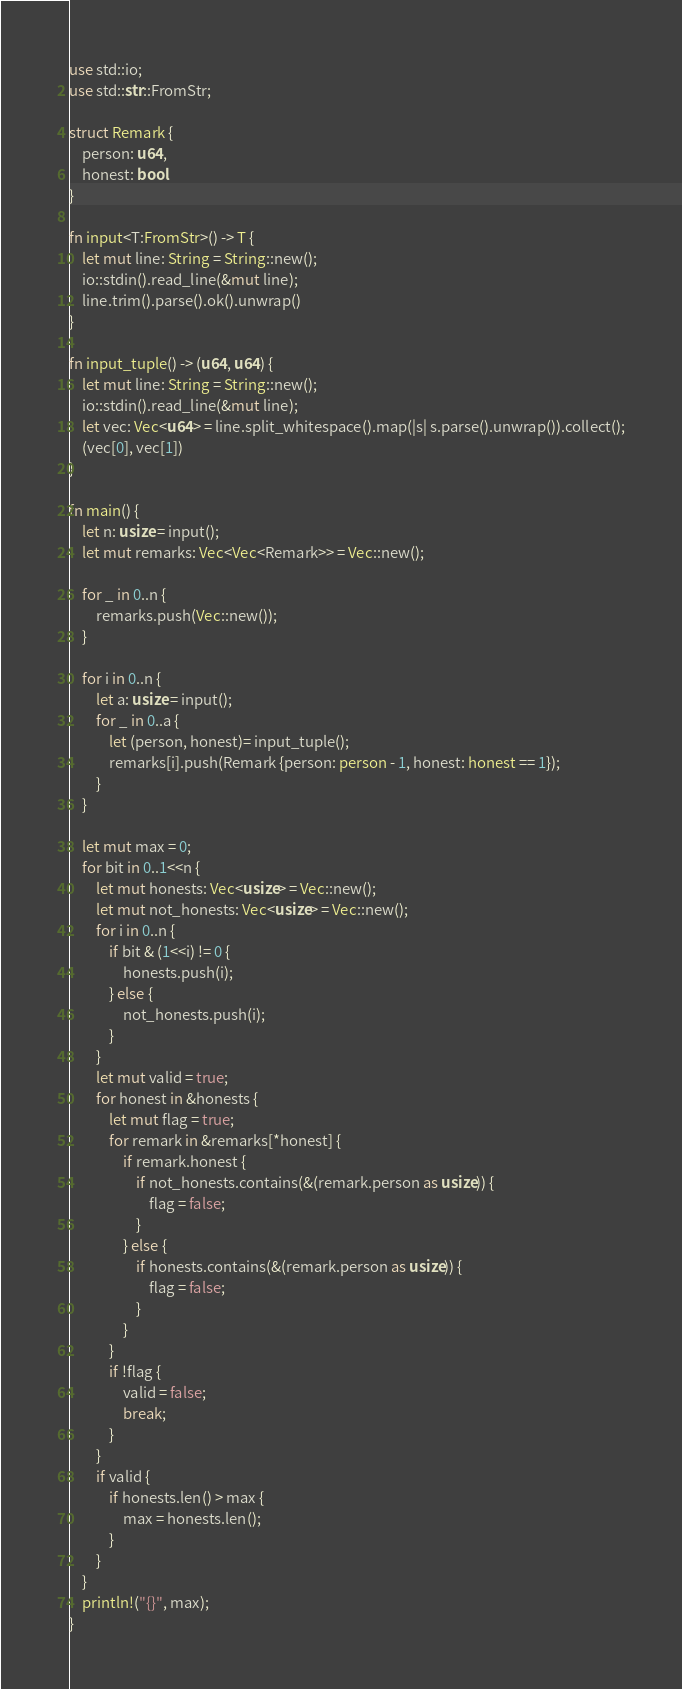Convert code to text. <code><loc_0><loc_0><loc_500><loc_500><_Rust_>use std::io;
use std::str::FromStr;

struct Remark {
    person: u64,
    honest: bool
}

fn input<T:FromStr>() -> T {
    let mut line: String = String::new();
    io::stdin().read_line(&mut line);
    line.trim().parse().ok().unwrap()
}

fn input_tuple() -> (u64, u64) {
    let mut line: String = String::new();
    io::stdin().read_line(&mut line);
    let vec: Vec<u64> = line.split_whitespace().map(|s| s.parse().unwrap()).collect();
    (vec[0], vec[1])
}

fn main() {
    let n: usize = input();
    let mut remarks: Vec<Vec<Remark>> = Vec::new();

    for _ in 0..n {
        remarks.push(Vec::new());
    }

    for i in 0..n {
        let a: usize = input();
        for _ in 0..a {
            let (person, honest)= input_tuple();
            remarks[i].push(Remark {person: person - 1, honest: honest == 1});
        }
    }

    let mut max = 0;
    for bit in 0..1<<n {
        let mut honests: Vec<usize> = Vec::new();
        let mut not_honests: Vec<usize> = Vec::new();
        for i in 0..n {
            if bit & (1<<i) != 0 {
                honests.push(i);
            } else {
                not_honests.push(i);
            }
        }
        let mut valid = true;
        for honest in &honests {
            let mut flag = true;
            for remark in &remarks[*honest] {
                if remark.honest {
                    if not_honests.contains(&(remark.person as usize)) {
                        flag = false;
                    }
                } else {
                    if honests.contains(&(remark.person as usize)) {
                        flag = false;
                    }
                }
            }
            if !flag {
                valid = false;
                break;
            }
        }
        if valid {
            if honests.len() > max {
                max = honests.len();
            }
        }
    }
    println!("{}", max);
}
</code> 